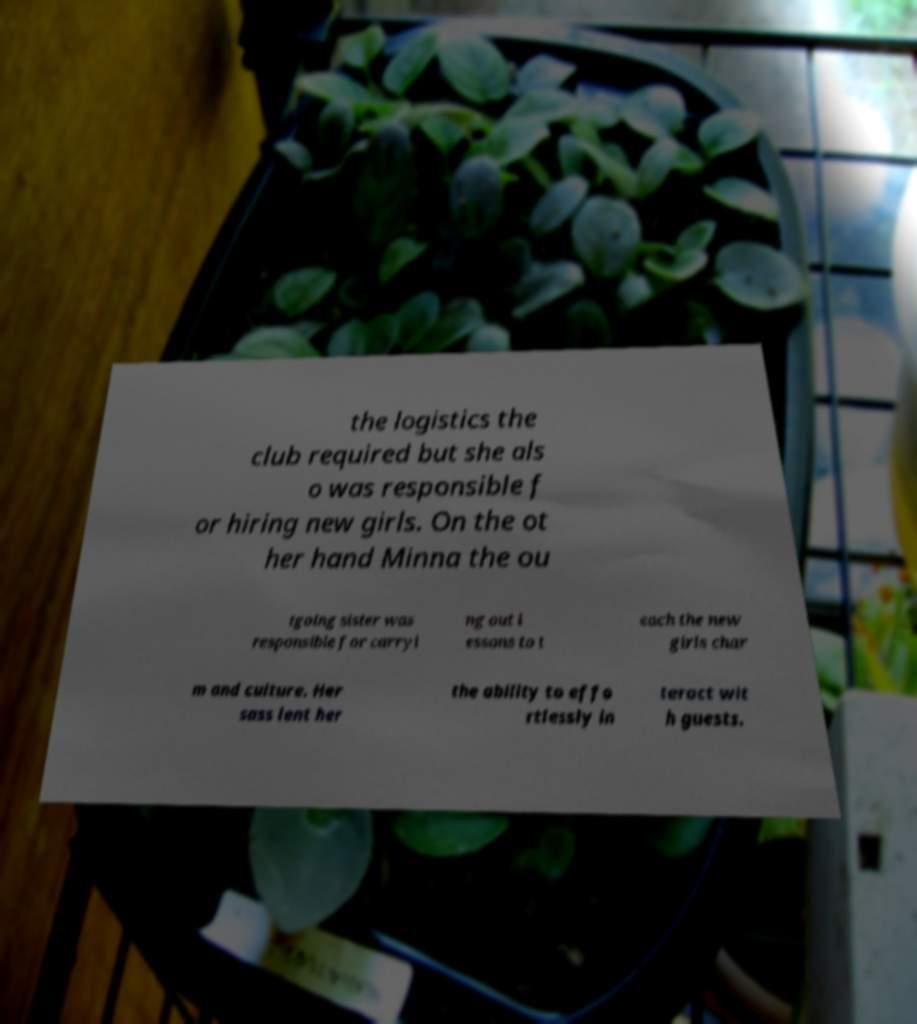Can you read and provide the text displayed in the image?This photo seems to have some interesting text. Can you extract and type it out for me? the logistics the club required but she als o was responsible f or hiring new girls. On the ot her hand Minna the ou tgoing sister was responsible for carryi ng out l essons to t each the new girls char m and culture. Her sass lent her the ability to effo rtlessly in teract wit h guests. 